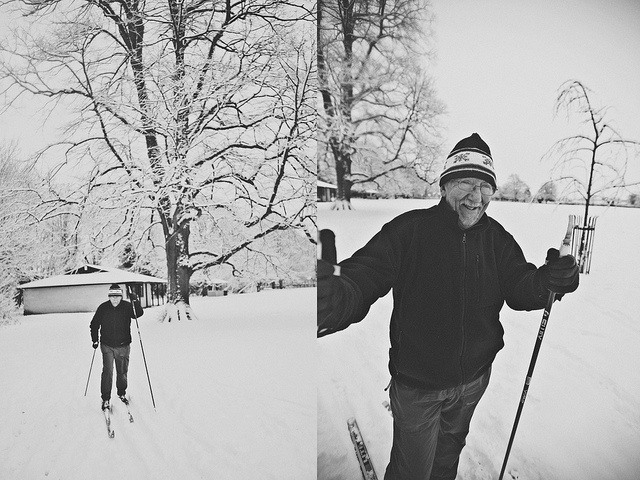Describe the objects in this image and their specific colors. I can see people in lightgray, black, gray, and darkgray tones, people in lightgray, black, gray, and darkgray tones, skis in lightgray, darkgray, gray, and black tones, and skis in lightgray, darkgray, gray, and black tones in this image. 